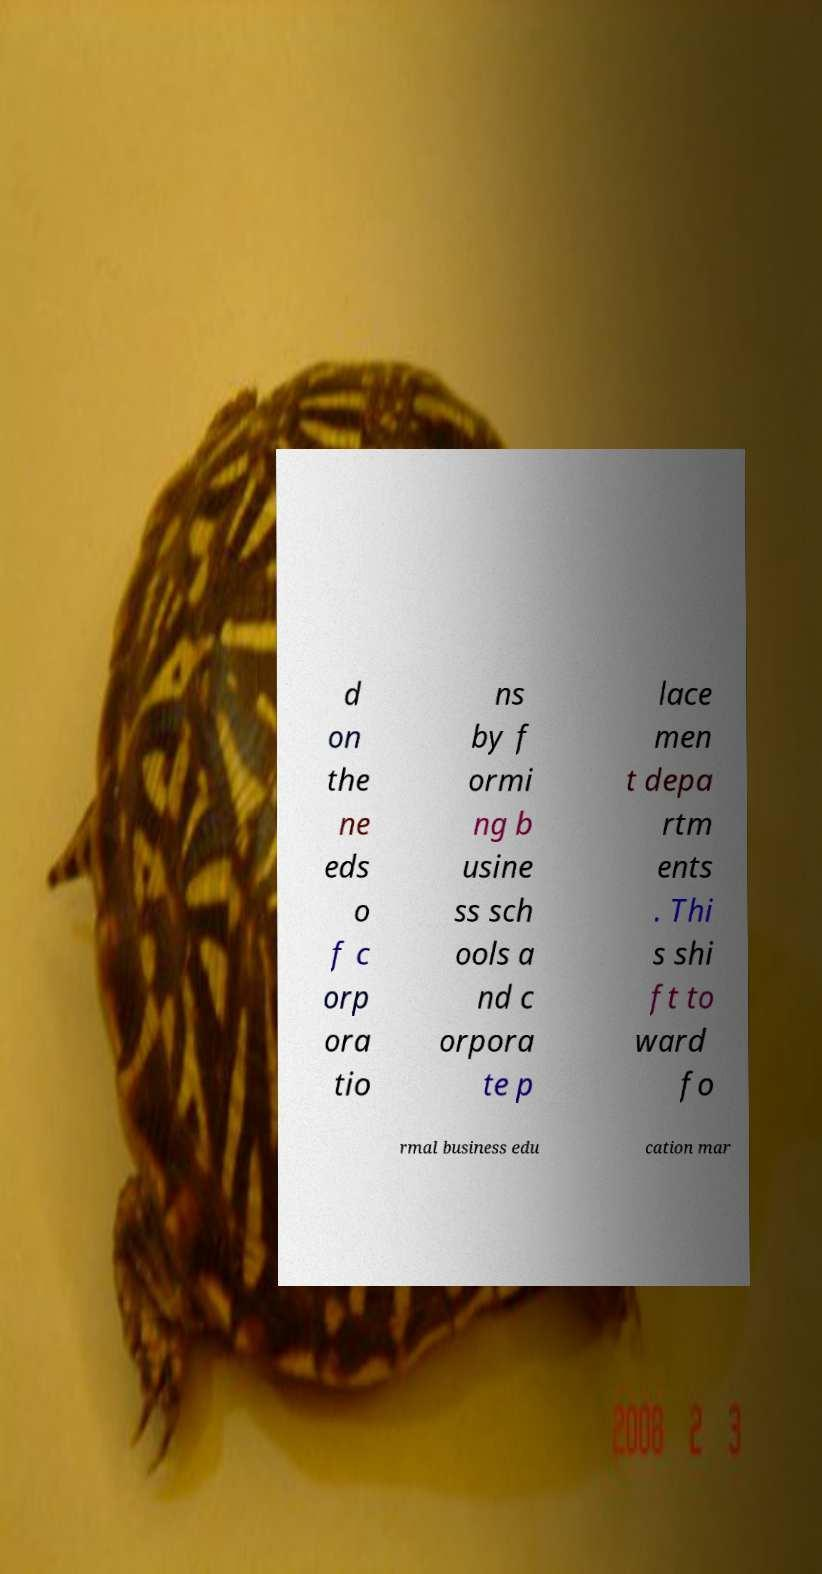Can you accurately transcribe the text from the provided image for me? d on the ne eds o f c orp ora tio ns by f ormi ng b usine ss sch ools a nd c orpora te p lace men t depa rtm ents . Thi s shi ft to ward fo rmal business edu cation mar 